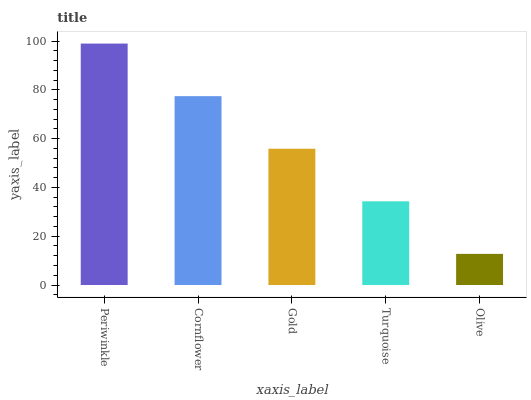Is Olive the minimum?
Answer yes or no. Yes. Is Periwinkle the maximum?
Answer yes or no. Yes. Is Cornflower the minimum?
Answer yes or no. No. Is Cornflower the maximum?
Answer yes or no. No. Is Periwinkle greater than Cornflower?
Answer yes or no. Yes. Is Cornflower less than Periwinkle?
Answer yes or no. Yes. Is Cornflower greater than Periwinkle?
Answer yes or no. No. Is Periwinkle less than Cornflower?
Answer yes or no. No. Is Gold the high median?
Answer yes or no. Yes. Is Gold the low median?
Answer yes or no. Yes. Is Cornflower the high median?
Answer yes or no. No. Is Turquoise the low median?
Answer yes or no. No. 